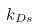Convert formula to latex. <formula><loc_0><loc_0><loc_500><loc_500>k _ { D s }</formula> 